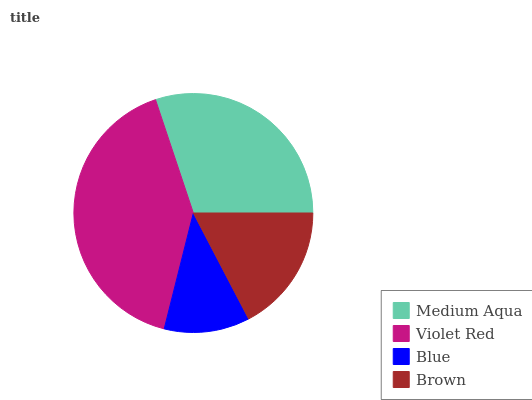Is Blue the minimum?
Answer yes or no. Yes. Is Violet Red the maximum?
Answer yes or no. Yes. Is Violet Red the minimum?
Answer yes or no. No. Is Blue the maximum?
Answer yes or no. No. Is Violet Red greater than Blue?
Answer yes or no. Yes. Is Blue less than Violet Red?
Answer yes or no. Yes. Is Blue greater than Violet Red?
Answer yes or no. No. Is Violet Red less than Blue?
Answer yes or no. No. Is Medium Aqua the high median?
Answer yes or no. Yes. Is Brown the low median?
Answer yes or no. Yes. Is Violet Red the high median?
Answer yes or no. No. Is Blue the low median?
Answer yes or no. No. 